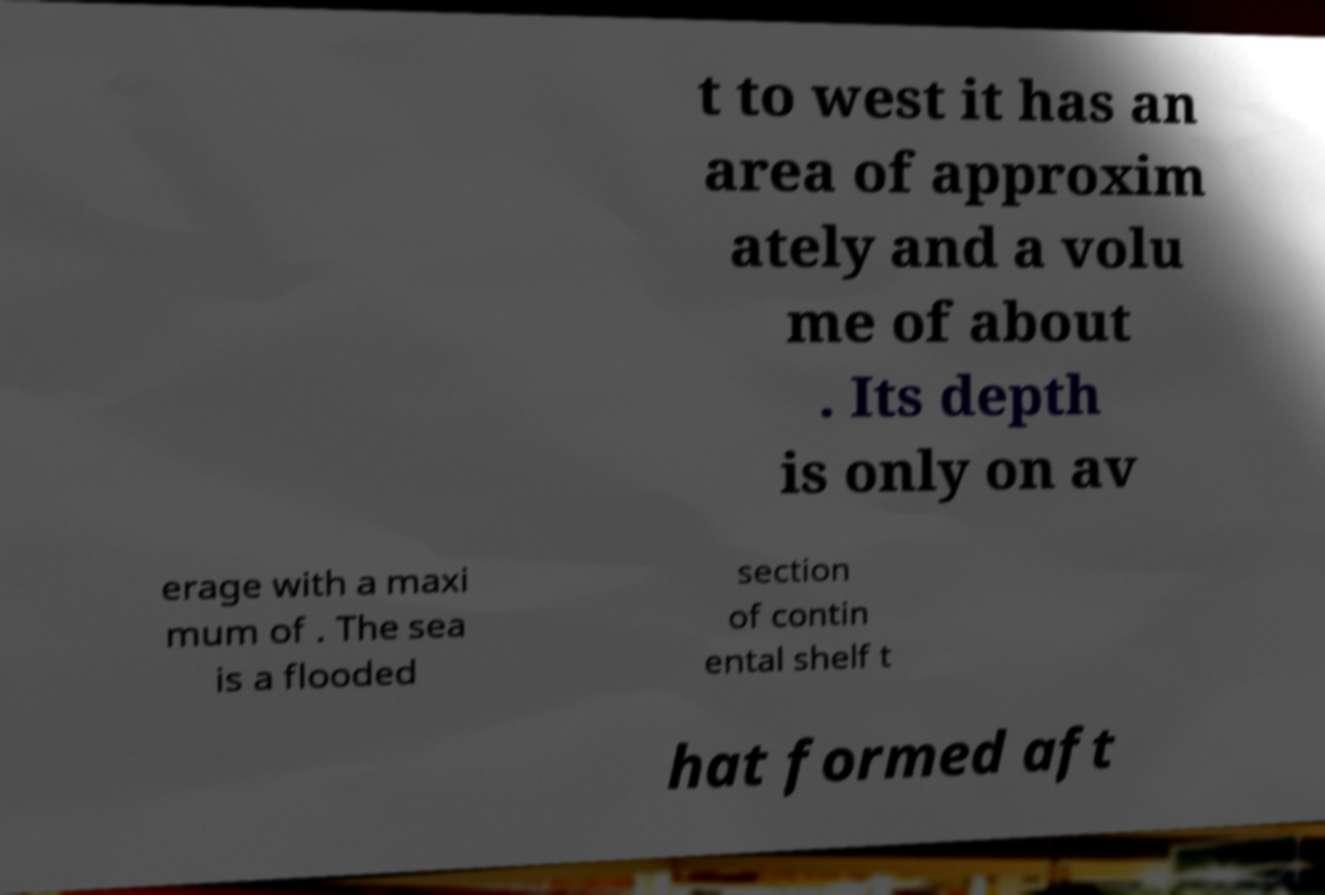Please read and relay the text visible in this image. What does it say? t to west it has an area of approxim ately and a volu me of about . Its depth is only on av erage with a maxi mum of . The sea is a flooded section of contin ental shelf t hat formed aft 